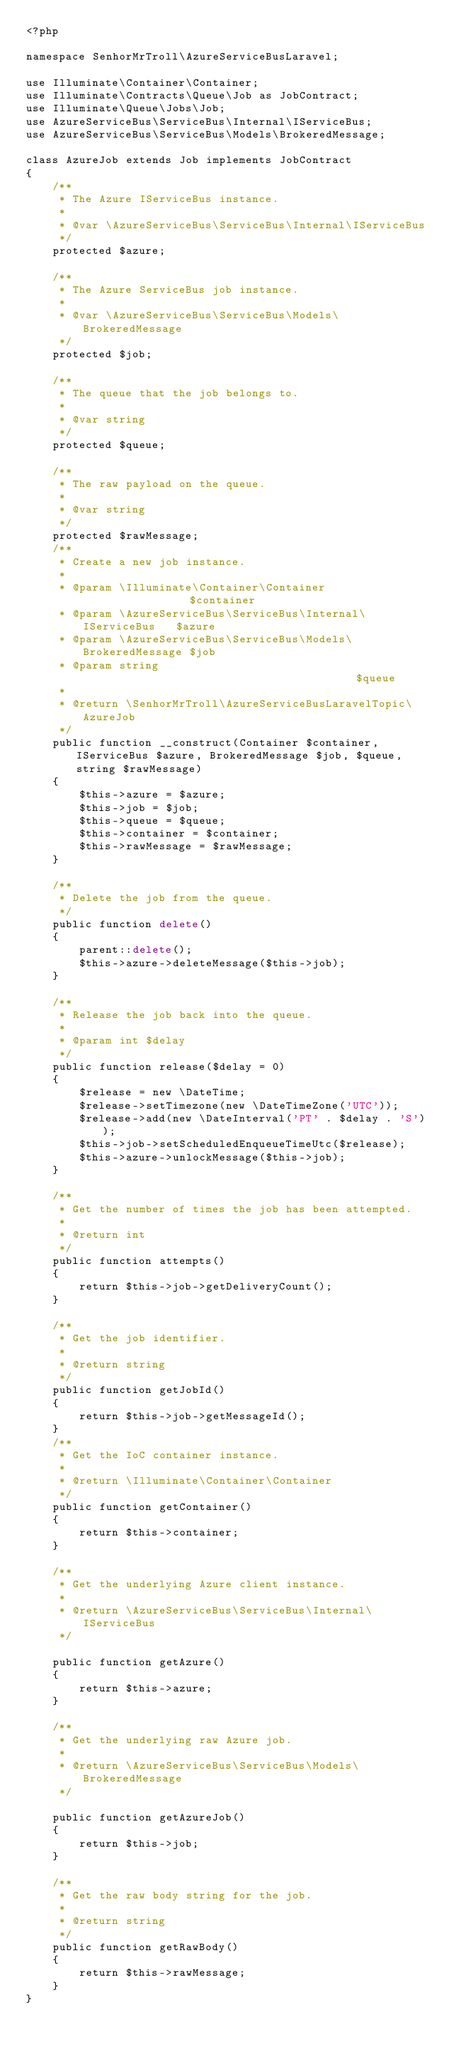Convert code to text. <code><loc_0><loc_0><loc_500><loc_500><_PHP_><?php

namespace SenhorMrTroll\AzureServiceBusLaravel;

use Illuminate\Container\Container;
use Illuminate\Contracts\Queue\Job as JobContract;
use Illuminate\Queue\Jobs\Job;
use AzureServiceBus\ServiceBus\Internal\IServiceBus;
use AzureServiceBus\ServiceBus\Models\BrokeredMessage;

class AzureJob extends Job implements JobContract
{
    /**
     * The Azure IServiceBus instance.
     *
     * @var \AzureServiceBus\ServiceBus\Internal\IServiceBus
     */
    protected $azure;

    /**
     * The Azure ServiceBus job instance.
     *
     * @var \AzureServiceBus\ServiceBus\Models\BrokeredMessage
     */
    protected $job;

    /**
     * The queue that the job belongs to.
     *
     * @var string
     */
    protected $queue;

    /**
     * The raw payload on the queue.
     *
     * @var string
     */
    protected $rawMessage;
    /**
     * Create a new job instance.
     *
     * @param \Illuminate\Container\Container                 $container
     * @param \AzureServiceBus\ServiceBus\Internal\IServiceBus   $azure
     * @param \AzureServiceBus\ServiceBus\Models\BrokeredMessage $job
     * @param string                                          $queue
     *
     * @return \SenhorMrTroll\AzureServiceBusLaravelTopic\AzureJob
     */
    public function __construct(Container $container, IServiceBus $azure, BrokeredMessage $job, $queue, string $rawMessage)
    {
        $this->azure = $azure;
        $this->job = $job;
        $this->queue = $queue;
        $this->container = $container;
        $this->rawMessage = $rawMessage;
    }

    /**
     * Delete the job from the queue.
     */
    public function delete()
    {
        parent::delete();
        $this->azure->deleteMessage($this->job);
    }

    /**
     * Release the job back into the queue.
     *
     * @param int $delay
     */
    public function release($delay = 0)
    {
        $release = new \DateTime;
        $release->setTimezone(new \DateTimeZone('UTC'));
        $release->add(new \DateInterval('PT' . $delay . 'S'));
        $this->job->setScheduledEnqueueTimeUtc($release);
        $this->azure->unlockMessage($this->job);
    }

    /**
     * Get the number of times the job has been attempted.
     *
     * @return int
     */
    public function attempts()
    {
        return $this->job->getDeliveryCount();
    }

    /**
     * Get the job identifier.
     *
     * @return string
     */
    public function getJobId()
    {
        return $this->job->getMessageId();
    }
    /**
     * Get the IoC container instance.
     *
     * @return \Illuminate\Container\Container
     */
    public function getContainer()
    {
        return $this->container;
    }

    /**
     * Get the underlying Azure client instance.
     *
     * @return \AzureServiceBus\ServiceBus\Internal\IServiceBus
     */

    public function getAzure()
    {
        return $this->azure;
    }

    /**
     * Get the underlying raw Azure job.
     *
     * @return \AzureServiceBus\ServiceBus\Models\BrokeredMessage
     */

    public function getAzureJob()
    {
        return $this->job;
    }

    /**
     * Get the raw body string for the job.
     *
     * @return string
     */
    public function getRawBody()
    {
        return $this->rawMessage;
    }
}
</code> 